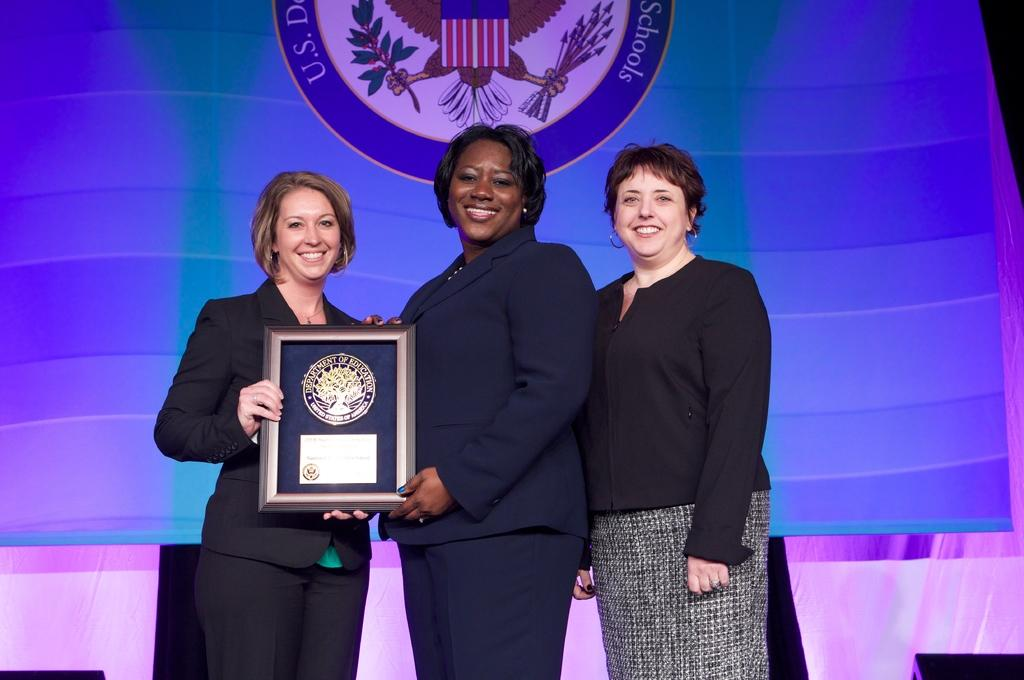What are the women in the image doing? The women are standing on a dais in the image. What are the women holding in the image? The women are holding a frame in the image. What can be seen in the background of the image? There is a screen and a curtain in the background of the image. What type of apparatus is the woman using to polish the jewel in the image? There is no apparatus or jewel present in the image. 